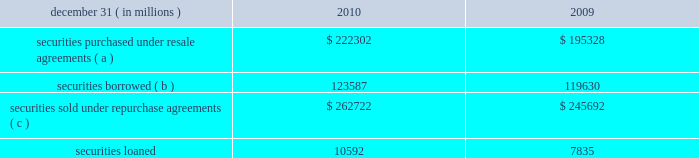Jpmorgan chase & co./2010 annual report 219 note 13 2013 securities financing activities jpmorgan chase enters into resale agreements , repurchase agreements , securities borrowed transactions and securities loaned transactions ( collectively , 201csecurities financing agree- ments 201d ) primarily to finance the firm 2019s inventory positions , ac- quire securities to cover short positions , accommodate customers 2019 financing needs , and settle other securities obligations .
Securities financing agreements are treated as collateralized financings on the firm 2019s consolidated balance sheets .
Resale and repurchase agreements are generally carried at the amounts at which the securities will be subsequently sold or repurchased , plus accrued interest .
Securities borrowed and securities loaned transactions are generally carried at the amount of cash collateral advanced or received .
Where appropriate under applicable ac- counting guidance , resale and repurchase agreements with the same counterparty are reported on a net basis .
Fees received or paid in connection with securities financing agreements are recorded in interest income or interest expense .
The firm has elected the fair value option for certain securities financing agreements .
For a further discussion of the fair value option , see note 4 on pages 187 2013189 of this annual report .
The securities financing agreements for which the fair value option has been elected are reported within securities purchased under resale agreements ; securities loaned or sold under repurchase agreements ; and securities borrowed on the consolidated bal- ance sheets .
Generally , for agreements carried at fair value , current-period interest accruals are recorded within interest income and interest expense , with changes in fair value reported in principal transactions revenue .
However , for financial instru- ments containing embedded derivatives that would be separately accounted for in accordance with accounting guidance for hybrid instruments , all changes in fair value , including any interest elements , are reported in principal transactions revenue .
The table details the firm 2019s securities financing agree- ments , all of which are accounted for as collateralized financings during the periods presented. .
( a ) includes resale agreements of $ 20.3 billion and $ 20.5 billion accounted for at fair value at december 31 , 2010 and 2009 , respectively .
( b ) includes securities borrowed of $ 14.0 billion and $ 7.0 billion accounted for at fair value at december 31 , 2010 and 2009 , respectively .
( c ) includes repurchase agreements of $ 4.1 billion and $ 3.4 billion accounted for at fair value at december 31 , 2010 and 2009 , respectively .
The amounts reported in the table above have been reduced by $ 112.7 billion and $ 121.2 billion at december 31 , 2010 and 2009 , respectively , as a result of agreements in effect that meet the specified conditions for net presentation under applicable accounting guidance .
Jpmorgan chase 2019s policy is to take possession , where possible , of securities purchased under resale agreements and of securi- ties borrowed .
The firm monitors the market value of the un- derlying securities that it has received from its counterparties and either requests additional collateral or returns a portion of the collateral when appropriate in light of the market value of the underlying securities .
Margin levels are established initially based upon the counterparty and type of collateral and moni- tored on an ongoing basis to protect against declines in collat- eral value in the event of default .
Jpmorgan chase typically enters into master netting agreements and other collateral arrangements with its resale agreement and securities bor- rowed counterparties , which provide for the right to liquidate the purchased or borrowed securities in the event of a customer default .
As a result of the firm 2019s credit risk mitigation practices described above on resale and securities borrowed agreements , the firm did not hold any reserves for credit impairment on these agreements as of december 31 , 2010 and 2009 .
For a further discussion of assets pledged and collateral received in securities financing agreements see note 31 on pages 280 2013 281 of this annual report. .
What were average repurchase agreements accounted for at fair value for 2010 and 2009 , in billions? 
Computations: ((4.1 + 3.4) / 2)
Answer: 3.75. 